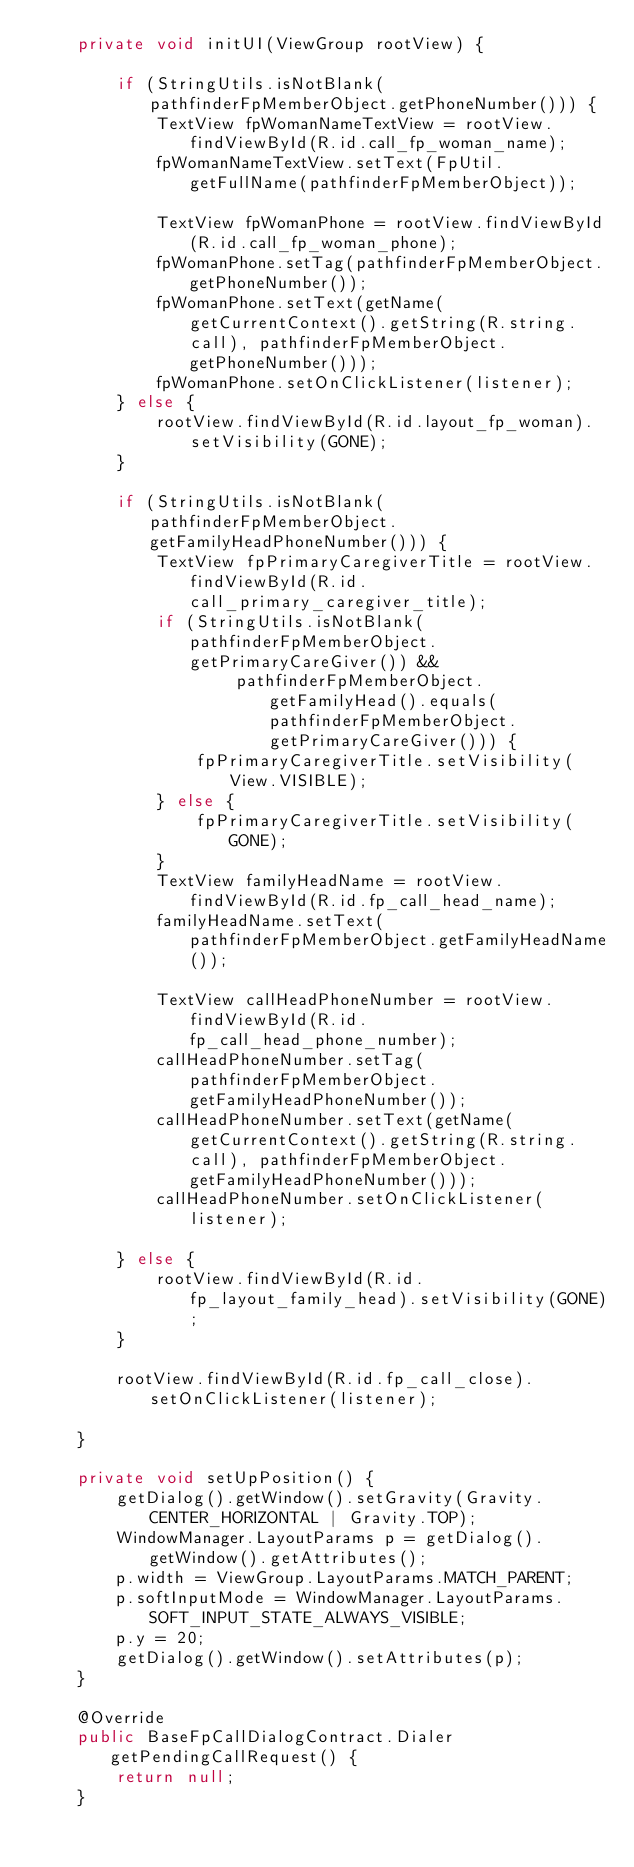Convert code to text. <code><loc_0><loc_0><loc_500><loc_500><_Java_>    private void initUI(ViewGroup rootView) {

        if (StringUtils.isNotBlank(pathfinderFpMemberObject.getPhoneNumber())) {
            TextView fpWomanNameTextView = rootView.findViewById(R.id.call_fp_woman_name);
            fpWomanNameTextView.setText(FpUtil.getFullName(pathfinderFpMemberObject));

            TextView fpWomanPhone = rootView.findViewById(R.id.call_fp_woman_phone);
            fpWomanPhone.setTag(pathfinderFpMemberObject.getPhoneNumber());
            fpWomanPhone.setText(getName(getCurrentContext().getString(R.string.call), pathfinderFpMemberObject.getPhoneNumber()));
            fpWomanPhone.setOnClickListener(listener);
        } else {
            rootView.findViewById(R.id.layout_fp_woman).setVisibility(GONE);
        }

        if (StringUtils.isNotBlank(pathfinderFpMemberObject.getFamilyHeadPhoneNumber())) {
            TextView fpPrimaryCaregiverTitle = rootView.findViewById(R.id.call_primary_caregiver_title);
            if (StringUtils.isNotBlank(pathfinderFpMemberObject.getPrimaryCareGiver()) &&
                    pathfinderFpMemberObject.getFamilyHead().equals(pathfinderFpMemberObject.getPrimaryCareGiver())) {
                fpPrimaryCaregiverTitle.setVisibility(View.VISIBLE);
            } else {
                fpPrimaryCaregiverTitle.setVisibility(GONE);
            }
            TextView familyHeadName = rootView.findViewById(R.id.fp_call_head_name);
            familyHeadName.setText(pathfinderFpMemberObject.getFamilyHeadName());

            TextView callHeadPhoneNumber = rootView.findViewById(R.id.fp_call_head_phone_number);
            callHeadPhoneNumber.setTag(pathfinderFpMemberObject.getFamilyHeadPhoneNumber());
            callHeadPhoneNumber.setText(getName(getCurrentContext().getString(R.string.call), pathfinderFpMemberObject.getFamilyHeadPhoneNumber()));
            callHeadPhoneNumber.setOnClickListener(listener);

        } else {
            rootView.findViewById(R.id.fp_layout_family_head).setVisibility(GONE);
        }

        rootView.findViewById(R.id.fp_call_close).setOnClickListener(listener);

    }

    private void setUpPosition() {
        getDialog().getWindow().setGravity(Gravity.CENTER_HORIZONTAL | Gravity.TOP);
        WindowManager.LayoutParams p = getDialog().getWindow().getAttributes();
        p.width = ViewGroup.LayoutParams.MATCH_PARENT;
        p.softInputMode = WindowManager.LayoutParams.SOFT_INPUT_STATE_ALWAYS_VISIBLE;
        p.y = 20;
        getDialog().getWindow().setAttributes(p);
    }

    @Override
    public BaseFpCallDialogContract.Dialer getPendingCallRequest() {
        return null;
    }
</code> 